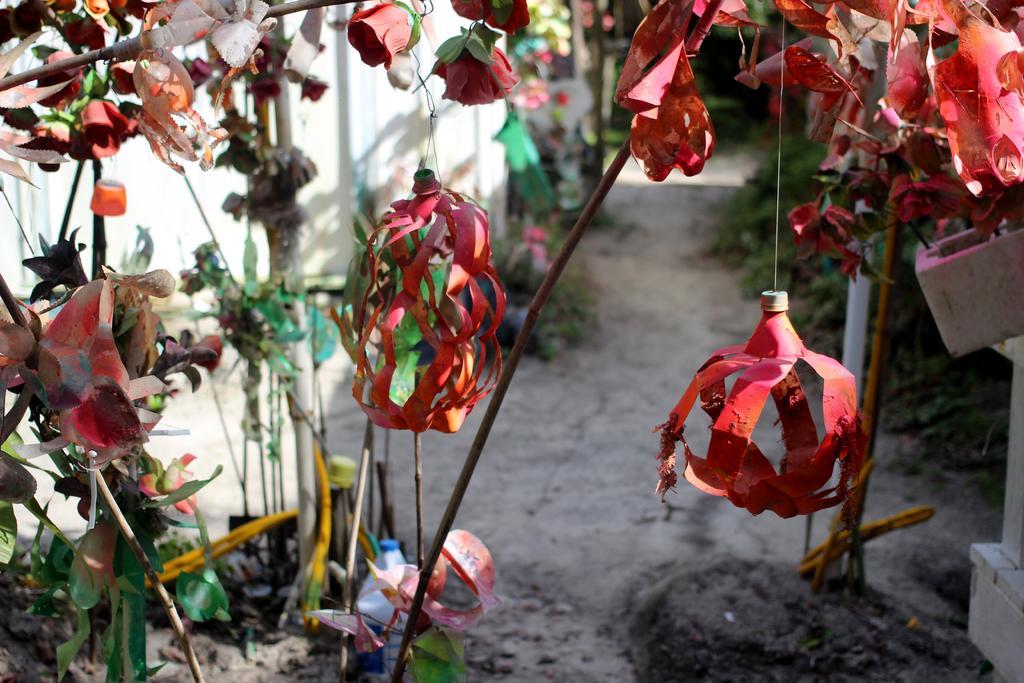Describe this image in one or two sentences. In this image, we can see some decors on the blur background. 